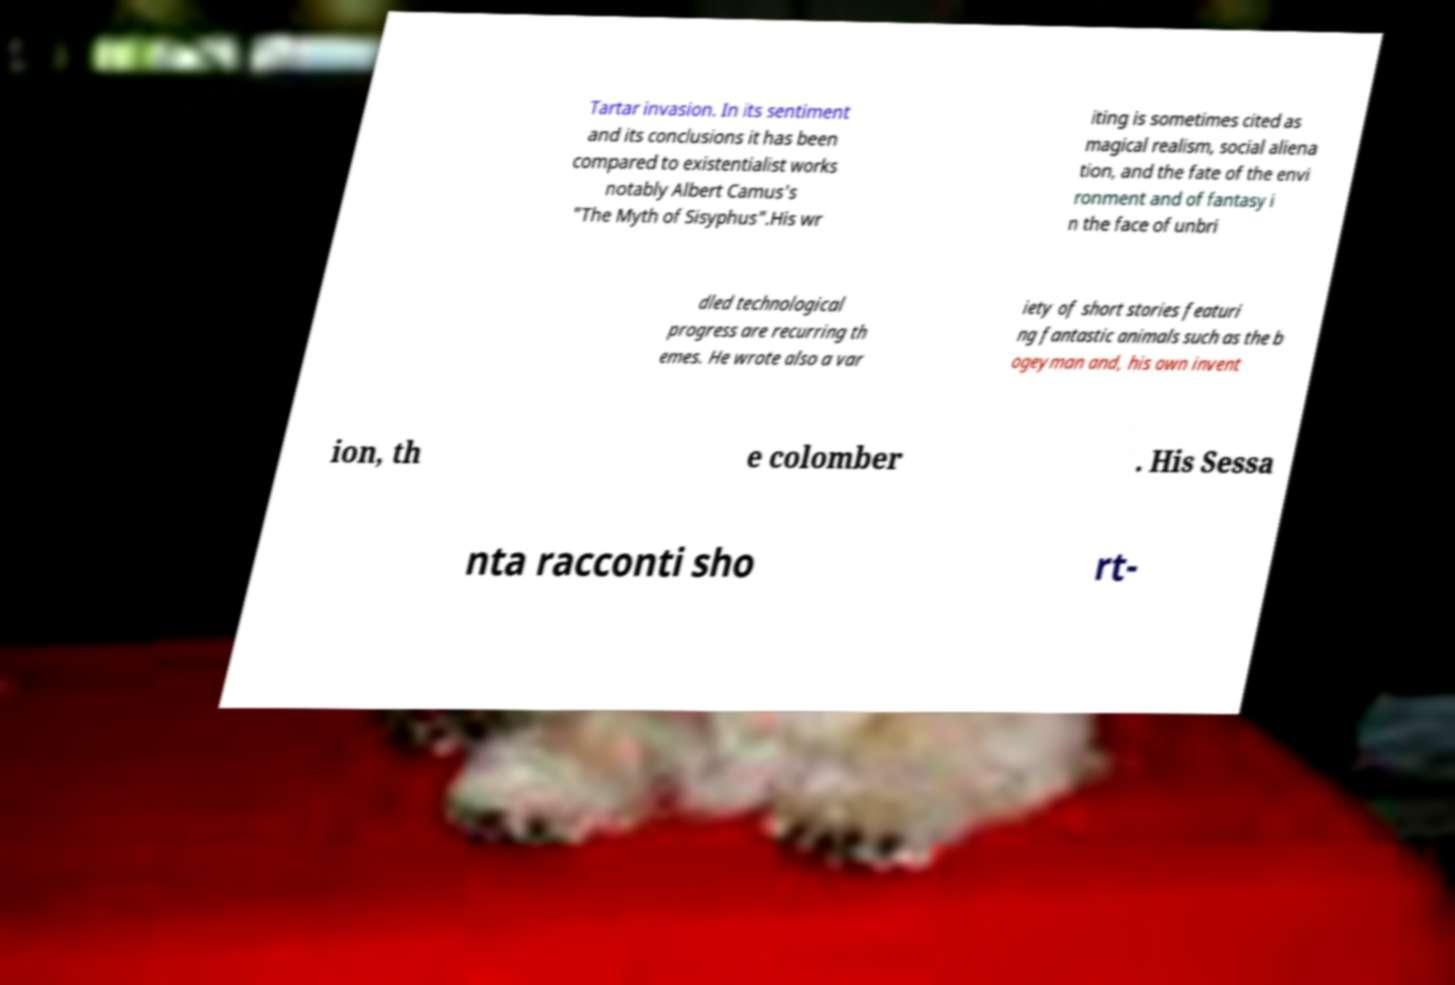Could you extract and type out the text from this image? Tartar invasion. In its sentiment and its conclusions it has been compared to existentialist works notably Albert Camus's "The Myth of Sisyphus".His wr iting is sometimes cited as magical realism, social aliena tion, and the fate of the envi ronment and of fantasy i n the face of unbri dled technological progress are recurring th emes. He wrote also a var iety of short stories featuri ng fantastic animals such as the b ogeyman and, his own invent ion, th e colomber . His Sessa nta racconti sho rt- 